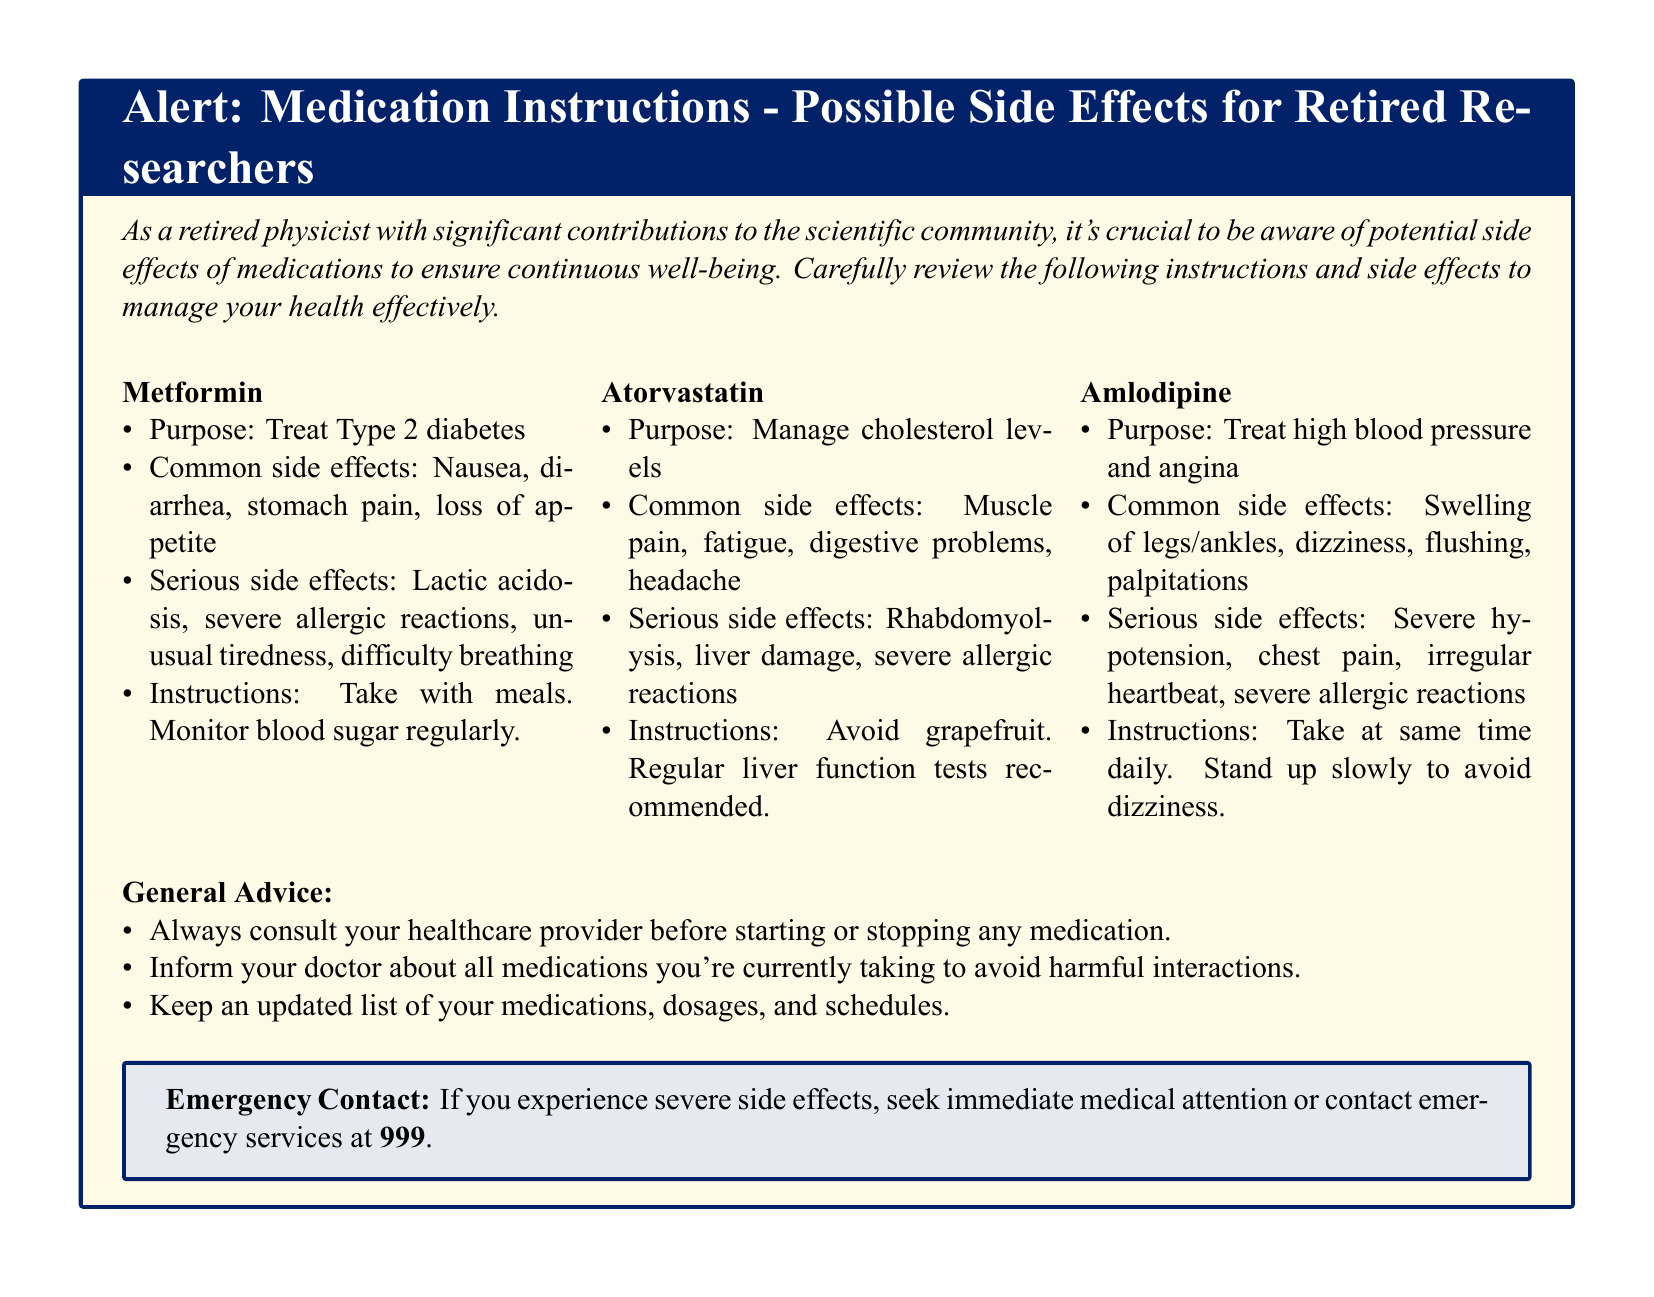What is the purpose of Metformin? The purpose of Metformin is to treat Type 2 diabetes as stated in the document.
Answer: Treat Type 2 diabetes What are the serious side effects of Atorvastatin? The serious side effects of Atorvastatin include rhabdomyolysis, liver damage, and severe allergic reactions according to the document.
Answer: Rhabdomyolysis, liver damage, severe allergic reactions What should you avoid while taking Atorvastatin? The document instructs to avoid grapefruit while taking Atorvastatin.
Answer: Grapefruit How often should Amlodipine be taken? The document advises to take Amlodipine at the same time daily.
Answer: Same time daily What is the emergency contact number for severe side effects? The document specifies that the emergency contact number is 999 for severe side effects.
Answer: 999 What common side effect is associated with Amlodipine? The common side effect associated with Amlodipine is swelling of legs/ankles as mentioned in the document.
Answer: Swelling of legs/ankles What general advice is provided before starting medication? The document states the advice to always consult your healthcare provider before starting or stopping any medication.
Answer: Consult your healthcare provider What kind of tests are recommended for Atorvastatin? The document recommends regular liver function tests for Atorvastatin.
Answer: Regular liver function tests What should you do if you experience severe side effects? The document instructs to seek immediate medical attention or contact emergency services if severe side effects occur.
Answer: Seek immediate medical attention 